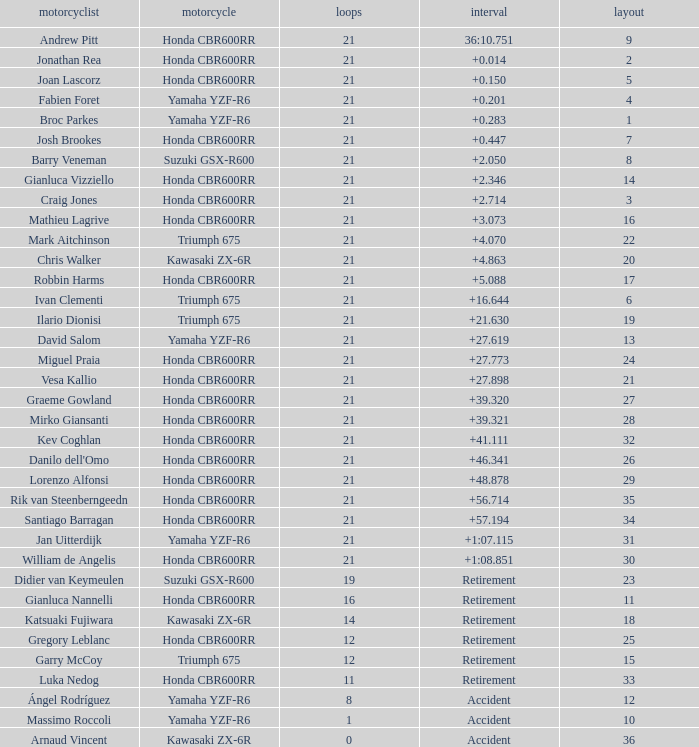What is the total of laps run by the driver with a grid under 17 and a time of +5.088? None. 